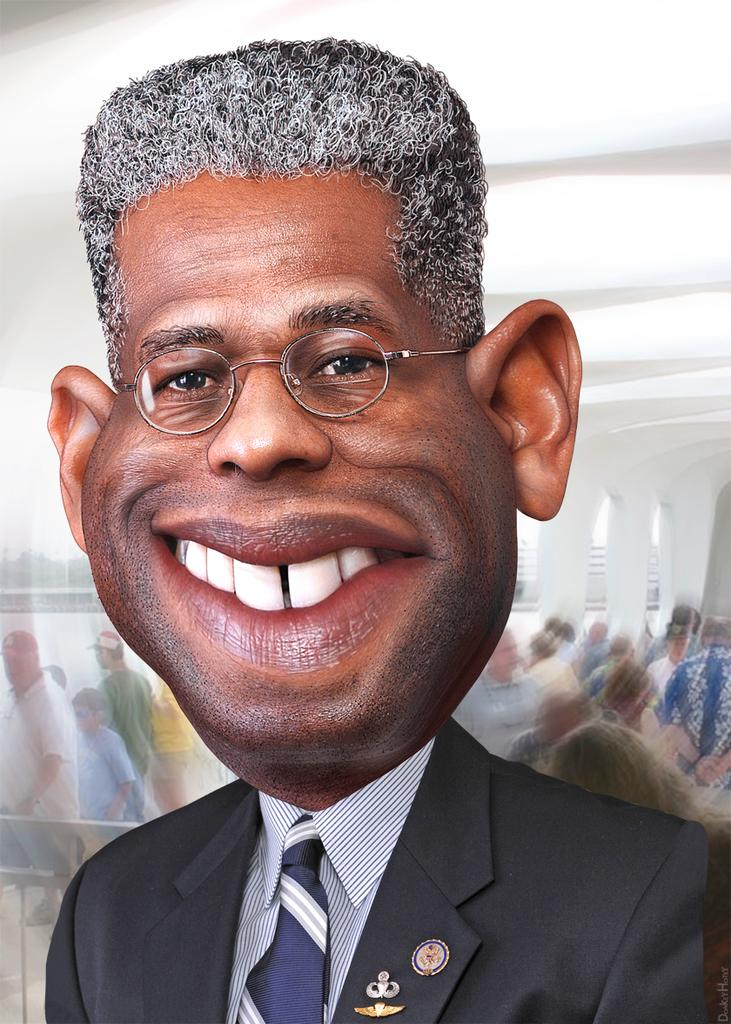What is the person in the image wearing? The person in the image is wearing a black suit. What is the person in the image doing? The person is standing. What can be seen happening in the background of the image? There are people walking in the background of the image. What type of beef is being cooked in the image? There is no beef or cooking activity present in the image. 